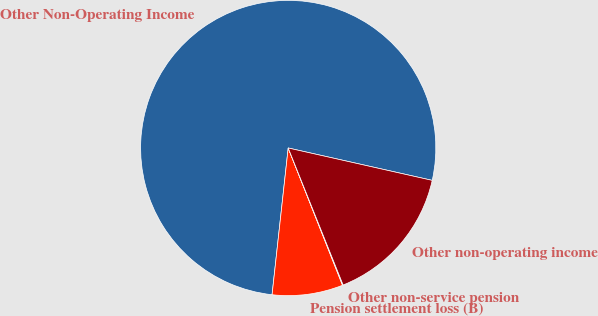Convert chart. <chart><loc_0><loc_0><loc_500><loc_500><pie_chart><fcel>Other Non-Operating Income<fcel>Pension settlement loss (B)<fcel>Other non-service pension<fcel>Other non-operating income<nl><fcel>76.77%<fcel>7.74%<fcel>0.07%<fcel>15.41%<nl></chart> 